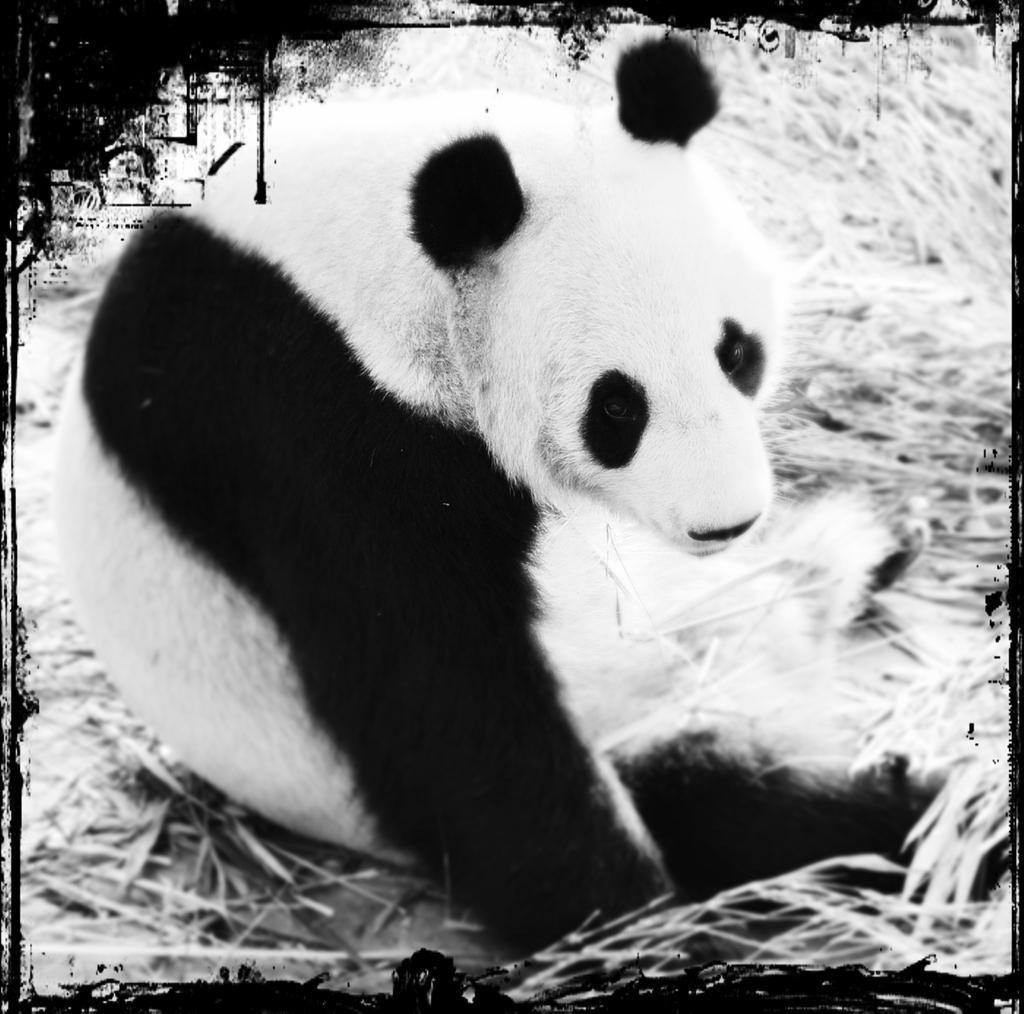Please provide a concise description of this image. This is a black and white picture, in this image we can see an animal on the ground and also we can see some grass. 